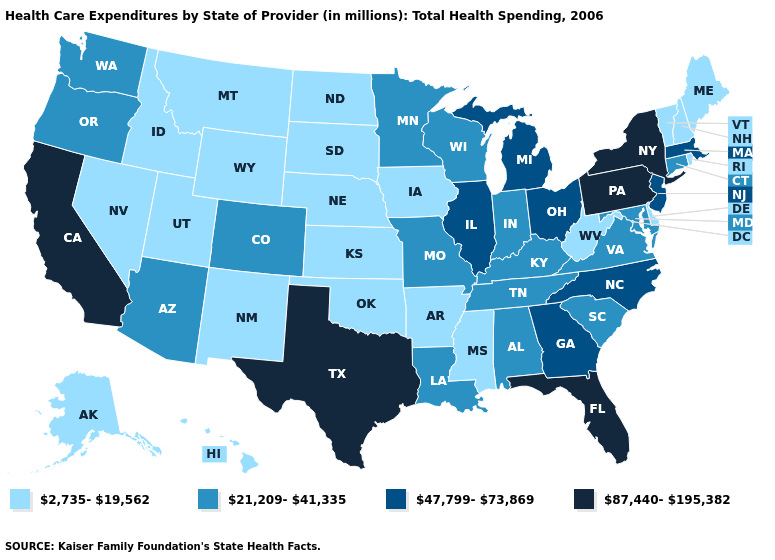Which states have the highest value in the USA?
Short answer required. California, Florida, New York, Pennsylvania, Texas. Which states have the lowest value in the USA?
Keep it brief. Alaska, Arkansas, Delaware, Hawaii, Idaho, Iowa, Kansas, Maine, Mississippi, Montana, Nebraska, Nevada, New Hampshire, New Mexico, North Dakota, Oklahoma, Rhode Island, South Dakota, Utah, Vermont, West Virginia, Wyoming. What is the value of Utah?
Write a very short answer. 2,735-19,562. Name the states that have a value in the range 47,799-73,869?
Keep it brief. Georgia, Illinois, Massachusetts, Michigan, New Jersey, North Carolina, Ohio. Which states have the lowest value in the USA?
Give a very brief answer. Alaska, Arkansas, Delaware, Hawaii, Idaho, Iowa, Kansas, Maine, Mississippi, Montana, Nebraska, Nevada, New Hampshire, New Mexico, North Dakota, Oklahoma, Rhode Island, South Dakota, Utah, Vermont, West Virginia, Wyoming. Name the states that have a value in the range 47,799-73,869?
Answer briefly. Georgia, Illinois, Massachusetts, Michigan, New Jersey, North Carolina, Ohio. What is the value of North Dakota?
Write a very short answer. 2,735-19,562. What is the highest value in states that border Maine?
Concise answer only. 2,735-19,562. Does California have the highest value in the West?
Answer briefly. Yes. Name the states that have a value in the range 47,799-73,869?
Give a very brief answer. Georgia, Illinois, Massachusetts, Michigan, New Jersey, North Carolina, Ohio. Which states hav the highest value in the South?
Short answer required. Florida, Texas. What is the lowest value in states that border South Dakota?
Short answer required. 2,735-19,562. Name the states that have a value in the range 47,799-73,869?
Keep it brief. Georgia, Illinois, Massachusetts, Michigan, New Jersey, North Carolina, Ohio. What is the value of Mississippi?
Short answer required. 2,735-19,562. Which states have the highest value in the USA?
Be succinct. California, Florida, New York, Pennsylvania, Texas. 